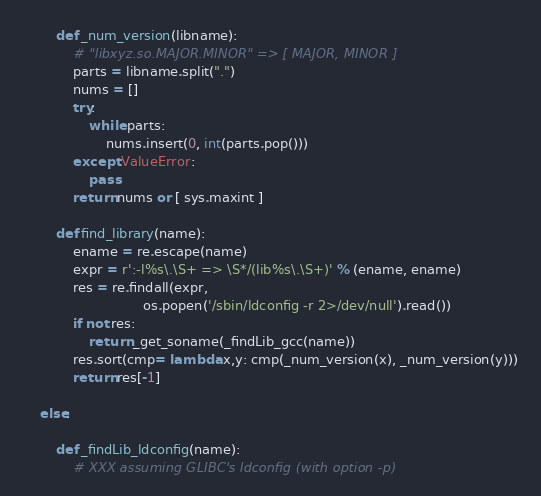<code> <loc_0><loc_0><loc_500><loc_500><_Python_>
        def _num_version(libname):
            # "libxyz.so.MAJOR.MINOR" => [ MAJOR, MINOR ]
            parts = libname.split(".")
            nums = []
            try:
                while parts:
                    nums.insert(0, int(parts.pop()))
            except ValueError:
                pass
            return nums or [ sys.maxint ]

        def find_library(name):
            ename = re.escape(name)
            expr = r':-l%s\.\S+ => \S*/(lib%s\.\S+)' % (ename, ename)
            res = re.findall(expr,
                             os.popen('/sbin/ldconfig -r 2>/dev/null').read())
            if not res:
                return _get_soname(_findLib_gcc(name))
            res.sort(cmp= lambda x,y: cmp(_num_version(x), _num_version(y)))
            return res[-1]

    else:

        def _findLib_ldconfig(name):
            # XXX assuming GLIBC's ldconfig (with option -p)</code> 